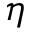<formula> <loc_0><loc_0><loc_500><loc_500>\eta</formula> 